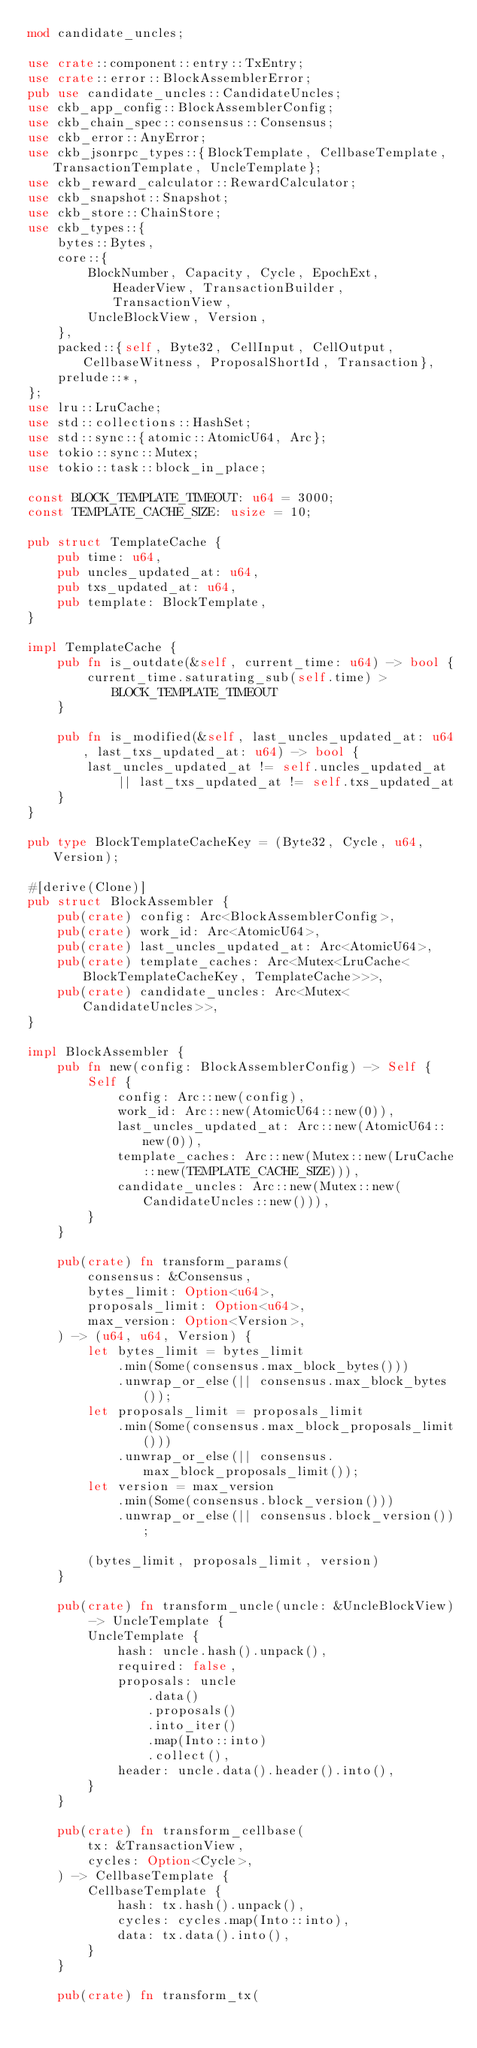Convert code to text. <code><loc_0><loc_0><loc_500><loc_500><_Rust_>mod candidate_uncles;

use crate::component::entry::TxEntry;
use crate::error::BlockAssemblerError;
pub use candidate_uncles::CandidateUncles;
use ckb_app_config::BlockAssemblerConfig;
use ckb_chain_spec::consensus::Consensus;
use ckb_error::AnyError;
use ckb_jsonrpc_types::{BlockTemplate, CellbaseTemplate, TransactionTemplate, UncleTemplate};
use ckb_reward_calculator::RewardCalculator;
use ckb_snapshot::Snapshot;
use ckb_store::ChainStore;
use ckb_types::{
    bytes::Bytes,
    core::{
        BlockNumber, Capacity, Cycle, EpochExt, HeaderView, TransactionBuilder, TransactionView,
        UncleBlockView, Version,
    },
    packed::{self, Byte32, CellInput, CellOutput, CellbaseWitness, ProposalShortId, Transaction},
    prelude::*,
};
use lru::LruCache;
use std::collections::HashSet;
use std::sync::{atomic::AtomicU64, Arc};
use tokio::sync::Mutex;
use tokio::task::block_in_place;

const BLOCK_TEMPLATE_TIMEOUT: u64 = 3000;
const TEMPLATE_CACHE_SIZE: usize = 10;

pub struct TemplateCache {
    pub time: u64,
    pub uncles_updated_at: u64,
    pub txs_updated_at: u64,
    pub template: BlockTemplate,
}

impl TemplateCache {
    pub fn is_outdate(&self, current_time: u64) -> bool {
        current_time.saturating_sub(self.time) > BLOCK_TEMPLATE_TIMEOUT
    }

    pub fn is_modified(&self, last_uncles_updated_at: u64, last_txs_updated_at: u64) -> bool {
        last_uncles_updated_at != self.uncles_updated_at
            || last_txs_updated_at != self.txs_updated_at
    }
}

pub type BlockTemplateCacheKey = (Byte32, Cycle, u64, Version);

#[derive(Clone)]
pub struct BlockAssembler {
    pub(crate) config: Arc<BlockAssemblerConfig>,
    pub(crate) work_id: Arc<AtomicU64>,
    pub(crate) last_uncles_updated_at: Arc<AtomicU64>,
    pub(crate) template_caches: Arc<Mutex<LruCache<BlockTemplateCacheKey, TemplateCache>>>,
    pub(crate) candidate_uncles: Arc<Mutex<CandidateUncles>>,
}

impl BlockAssembler {
    pub fn new(config: BlockAssemblerConfig) -> Self {
        Self {
            config: Arc::new(config),
            work_id: Arc::new(AtomicU64::new(0)),
            last_uncles_updated_at: Arc::new(AtomicU64::new(0)),
            template_caches: Arc::new(Mutex::new(LruCache::new(TEMPLATE_CACHE_SIZE))),
            candidate_uncles: Arc::new(Mutex::new(CandidateUncles::new())),
        }
    }

    pub(crate) fn transform_params(
        consensus: &Consensus,
        bytes_limit: Option<u64>,
        proposals_limit: Option<u64>,
        max_version: Option<Version>,
    ) -> (u64, u64, Version) {
        let bytes_limit = bytes_limit
            .min(Some(consensus.max_block_bytes()))
            .unwrap_or_else(|| consensus.max_block_bytes());
        let proposals_limit = proposals_limit
            .min(Some(consensus.max_block_proposals_limit()))
            .unwrap_or_else(|| consensus.max_block_proposals_limit());
        let version = max_version
            .min(Some(consensus.block_version()))
            .unwrap_or_else(|| consensus.block_version());

        (bytes_limit, proposals_limit, version)
    }

    pub(crate) fn transform_uncle(uncle: &UncleBlockView) -> UncleTemplate {
        UncleTemplate {
            hash: uncle.hash().unpack(),
            required: false,
            proposals: uncle
                .data()
                .proposals()
                .into_iter()
                .map(Into::into)
                .collect(),
            header: uncle.data().header().into(),
        }
    }

    pub(crate) fn transform_cellbase(
        tx: &TransactionView,
        cycles: Option<Cycle>,
    ) -> CellbaseTemplate {
        CellbaseTemplate {
            hash: tx.hash().unpack(),
            cycles: cycles.map(Into::into),
            data: tx.data().into(),
        }
    }

    pub(crate) fn transform_tx(</code> 